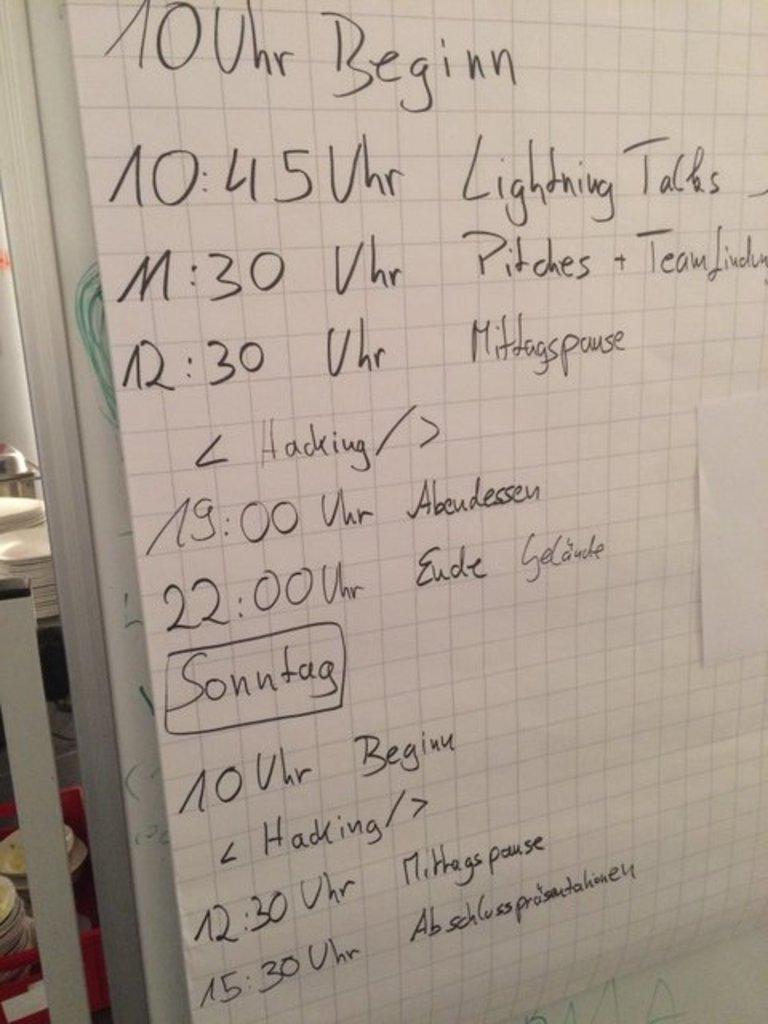What is on the last row of text?
Ensure brevity in your answer.  15:30 vhr abschlussproisertahoney. 